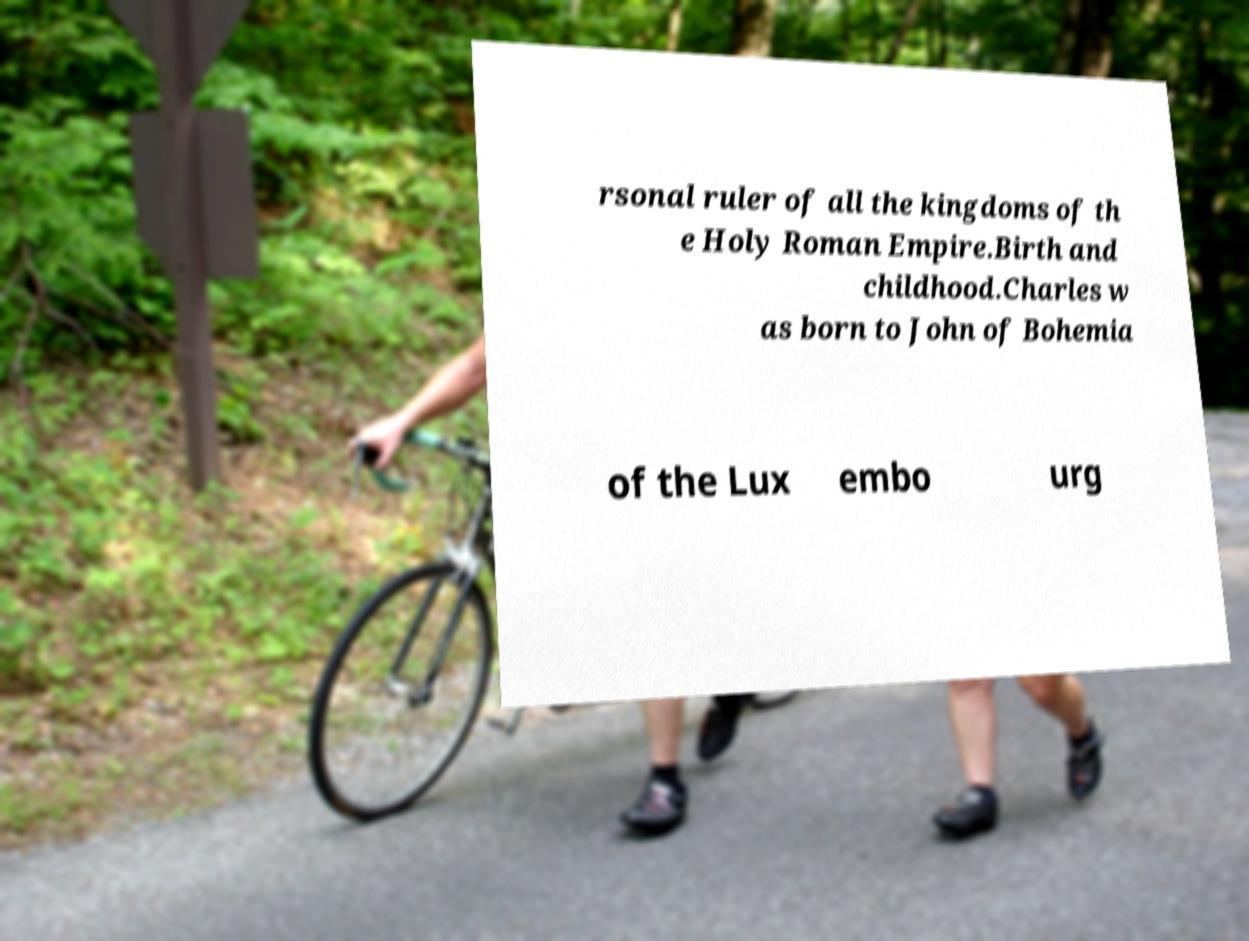Please identify and transcribe the text found in this image. rsonal ruler of all the kingdoms of th e Holy Roman Empire.Birth and childhood.Charles w as born to John of Bohemia of the Lux embo urg 